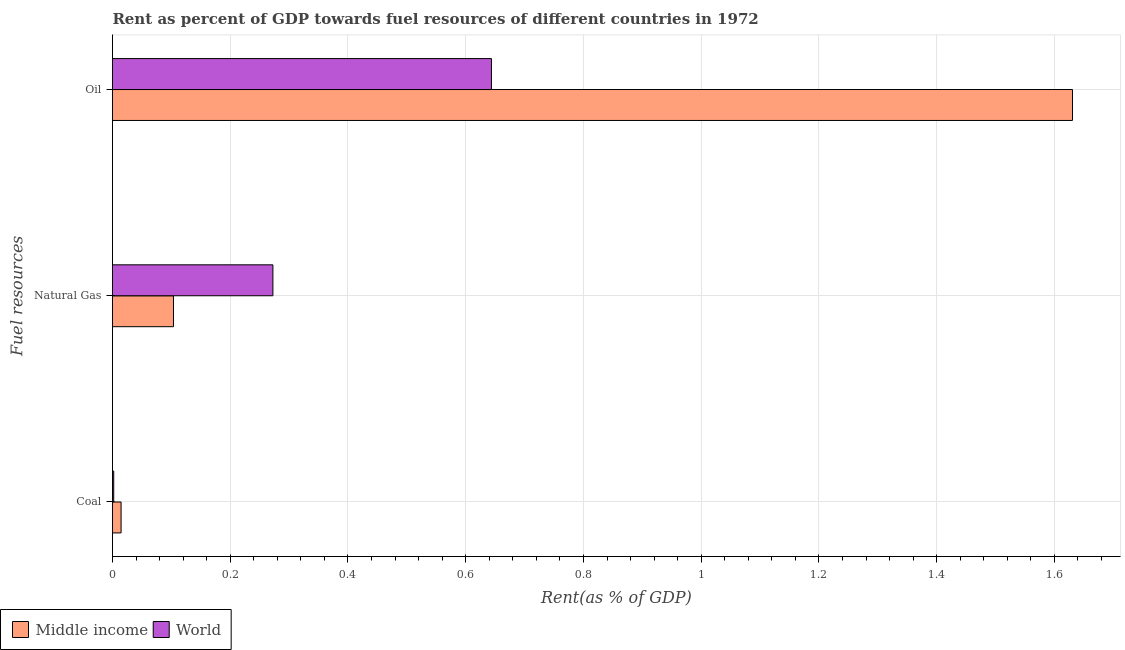How many groups of bars are there?
Your answer should be compact. 3. Are the number of bars per tick equal to the number of legend labels?
Offer a terse response. Yes. Are the number of bars on each tick of the Y-axis equal?
Provide a short and direct response. Yes. What is the label of the 2nd group of bars from the top?
Provide a succinct answer. Natural Gas. What is the rent towards coal in Middle income?
Your response must be concise. 0.01. Across all countries, what is the maximum rent towards coal?
Keep it short and to the point. 0.01. Across all countries, what is the minimum rent towards coal?
Give a very brief answer. 0. In which country was the rent towards oil maximum?
Keep it short and to the point. Middle income. In which country was the rent towards oil minimum?
Your answer should be compact. World. What is the total rent towards coal in the graph?
Offer a very short reply. 0.02. What is the difference between the rent towards coal in Middle income and that in World?
Provide a short and direct response. 0.01. What is the difference between the rent towards coal in World and the rent towards oil in Middle income?
Your answer should be compact. -1.63. What is the average rent towards oil per country?
Offer a terse response. 1.14. What is the difference between the rent towards natural gas and rent towards oil in World?
Provide a succinct answer. -0.37. What is the ratio of the rent towards oil in World to that in Middle income?
Make the answer very short. 0.39. Is the rent towards oil in World less than that in Middle income?
Your answer should be very brief. Yes. Is the difference between the rent towards oil in Middle income and World greater than the difference between the rent towards natural gas in Middle income and World?
Provide a succinct answer. Yes. What is the difference between the highest and the second highest rent towards natural gas?
Ensure brevity in your answer.  0.17. What is the difference between the highest and the lowest rent towards oil?
Provide a short and direct response. 0.99. In how many countries, is the rent towards natural gas greater than the average rent towards natural gas taken over all countries?
Give a very brief answer. 1. What does the 1st bar from the bottom in Coal represents?
Give a very brief answer. Middle income. Is it the case that in every country, the sum of the rent towards coal and rent towards natural gas is greater than the rent towards oil?
Keep it short and to the point. No. How many bars are there?
Provide a succinct answer. 6. How many countries are there in the graph?
Keep it short and to the point. 2. How many legend labels are there?
Provide a short and direct response. 2. What is the title of the graph?
Your answer should be very brief. Rent as percent of GDP towards fuel resources of different countries in 1972. Does "Honduras" appear as one of the legend labels in the graph?
Provide a succinct answer. No. What is the label or title of the X-axis?
Provide a succinct answer. Rent(as % of GDP). What is the label or title of the Y-axis?
Your answer should be compact. Fuel resources. What is the Rent(as % of GDP) of Middle income in Coal?
Your answer should be very brief. 0.01. What is the Rent(as % of GDP) of World in Coal?
Provide a succinct answer. 0. What is the Rent(as % of GDP) in Middle income in Natural Gas?
Provide a short and direct response. 0.1. What is the Rent(as % of GDP) of World in Natural Gas?
Your answer should be very brief. 0.27. What is the Rent(as % of GDP) of Middle income in Oil?
Make the answer very short. 1.63. What is the Rent(as % of GDP) of World in Oil?
Offer a terse response. 0.64. Across all Fuel resources, what is the maximum Rent(as % of GDP) of Middle income?
Give a very brief answer. 1.63. Across all Fuel resources, what is the maximum Rent(as % of GDP) of World?
Offer a terse response. 0.64. Across all Fuel resources, what is the minimum Rent(as % of GDP) in Middle income?
Keep it short and to the point. 0.01. Across all Fuel resources, what is the minimum Rent(as % of GDP) of World?
Your answer should be very brief. 0. What is the total Rent(as % of GDP) in Middle income in the graph?
Offer a terse response. 1.75. What is the total Rent(as % of GDP) in World in the graph?
Your response must be concise. 0.92. What is the difference between the Rent(as % of GDP) of Middle income in Coal and that in Natural Gas?
Keep it short and to the point. -0.09. What is the difference between the Rent(as % of GDP) in World in Coal and that in Natural Gas?
Provide a succinct answer. -0.27. What is the difference between the Rent(as % of GDP) of Middle income in Coal and that in Oil?
Your answer should be very brief. -1.62. What is the difference between the Rent(as % of GDP) of World in Coal and that in Oil?
Make the answer very short. -0.64. What is the difference between the Rent(as % of GDP) in Middle income in Natural Gas and that in Oil?
Offer a very short reply. -1.53. What is the difference between the Rent(as % of GDP) in World in Natural Gas and that in Oil?
Ensure brevity in your answer.  -0.37. What is the difference between the Rent(as % of GDP) of Middle income in Coal and the Rent(as % of GDP) of World in Natural Gas?
Your answer should be very brief. -0.26. What is the difference between the Rent(as % of GDP) of Middle income in Coal and the Rent(as % of GDP) of World in Oil?
Provide a short and direct response. -0.63. What is the difference between the Rent(as % of GDP) in Middle income in Natural Gas and the Rent(as % of GDP) in World in Oil?
Your response must be concise. -0.54. What is the average Rent(as % of GDP) in Middle income per Fuel resources?
Give a very brief answer. 0.58. What is the average Rent(as % of GDP) in World per Fuel resources?
Offer a very short reply. 0.31. What is the difference between the Rent(as % of GDP) of Middle income and Rent(as % of GDP) of World in Coal?
Provide a short and direct response. 0.01. What is the difference between the Rent(as % of GDP) in Middle income and Rent(as % of GDP) in World in Natural Gas?
Provide a short and direct response. -0.17. What is the ratio of the Rent(as % of GDP) in Middle income in Coal to that in Natural Gas?
Your answer should be very brief. 0.14. What is the ratio of the Rent(as % of GDP) of World in Coal to that in Natural Gas?
Ensure brevity in your answer.  0.01. What is the ratio of the Rent(as % of GDP) in Middle income in Coal to that in Oil?
Your response must be concise. 0.01. What is the ratio of the Rent(as % of GDP) of World in Coal to that in Oil?
Keep it short and to the point. 0. What is the ratio of the Rent(as % of GDP) in Middle income in Natural Gas to that in Oil?
Keep it short and to the point. 0.06. What is the ratio of the Rent(as % of GDP) of World in Natural Gas to that in Oil?
Ensure brevity in your answer.  0.42. What is the difference between the highest and the second highest Rent(as % of GDP) of Middle income?
Offer a very short reply. 1.53. What is the difference between the highest and the second highest Rent(as % of GDP) in World?
Your answer should be very brief. 0.37. What is the difference between the highest and the lowest Rent(as % of GDP) in Middle income?
Keep it short and to the point. 1.62. What is the difference between the highest and the lowest Rent(as % of GDP) of World?
Your response must be concise. 0.64. 